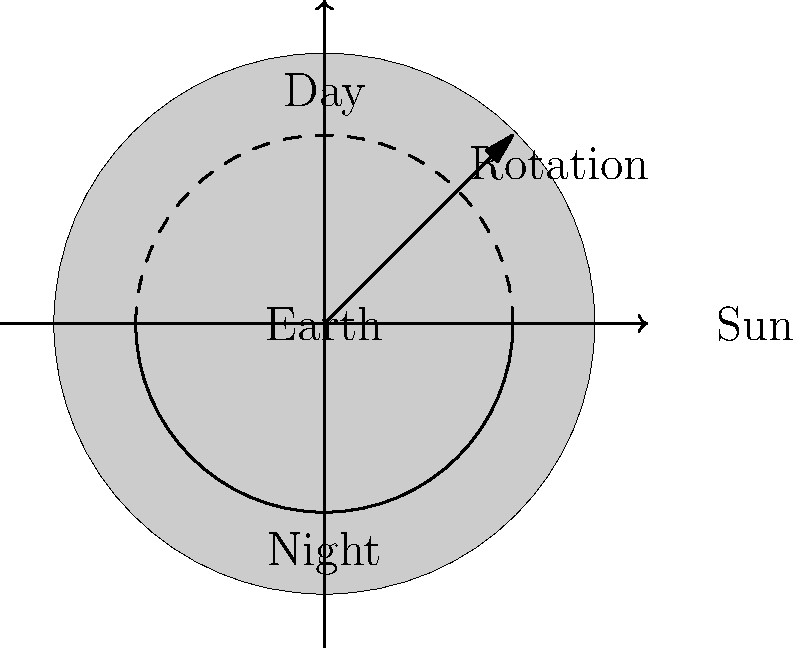As you look through your wedding photos from many years ago, you notice how the sunlight changed throughout the day. This reminds you of Earth's rotation. If the Earth rotates completely on its axis once every 24 hours, how many degrees does it rotate per hour? Let's approach this step-by-step:

1. First, recall that a full rotation of the Earth is 360°.
   $360°$ = 1 complete rotation

2. We know that the Earth completes this rotation in 24 hours.
   $24$ hours = 1 complete rotation

3. To find the degrees rotated per hour, we need to divide the total degrees by the total hours:

   $\text{Degrees per hour} = \frac{\text{Total degrees}}{\text{Total hours}}$

4. Substituting our values:

   $\text{Degrees per hour} = \frac{360°}{24 \text{ hours}}$

5. Simplifying:

   $\text{Degrees per hour} = 15°$

Therefore, the Earth rotates 15° per hour.
Answer: 15° 